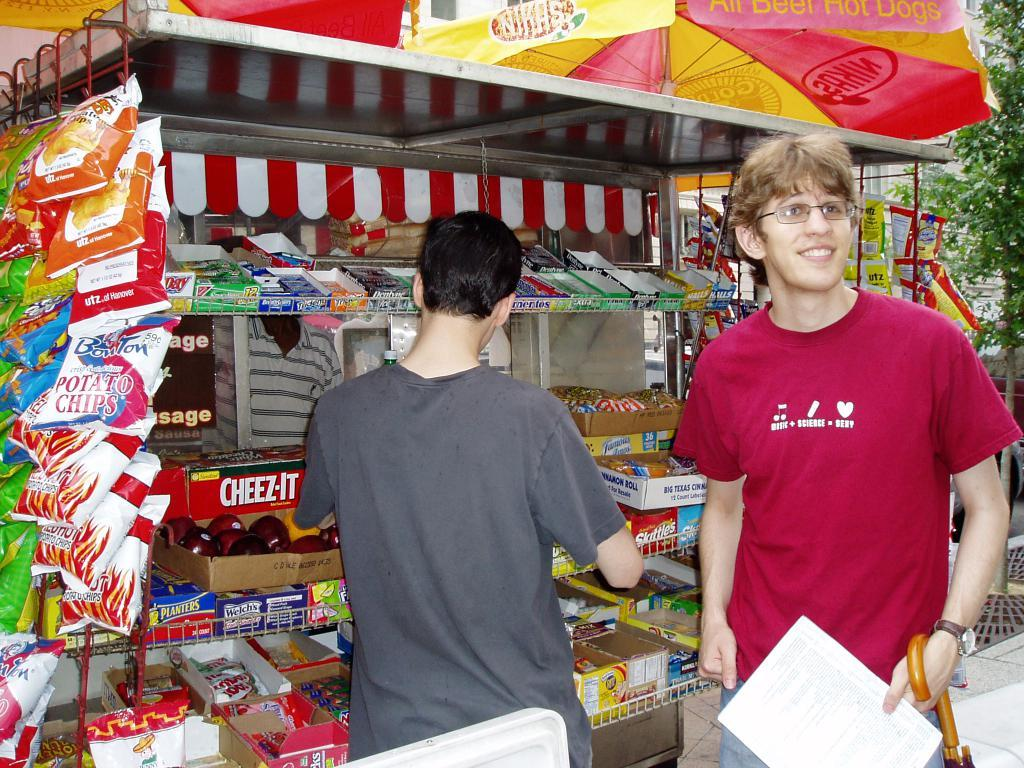<image>
Relay a brief, clear account of the picture shown. Two men at a food stand that sells Cheez-Its, potato chips and candy. 